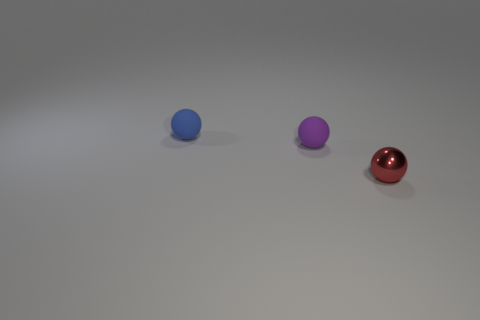What shape is the small object that is to the right of the tiny blue matte object and behind the red metallic sphere?
Offer a very short reply. Sphere. How many tiny things are on the right side of the small matte sphere that is in front of the tiny blue matte ball?
Make the answer very short. 1. Are the tiny object that is to the left of the tiny purple rubber sphere and the purple sphere made of the same material?
Your response must be concise. Yes. Is there any other thing that has the same material as the red sphere?
Provide a short and direct response. No. What is the size of the sphere in front of the rubber ball that is in front of the small blue rubber object?
Your response must be concise. Small. There is a rubber thing that is behind the matte sphere on the right side of the small matte sphere on the left side of the purple ball; what is its size?
Provide a succinct answer. Small. There is a tiny matte object in front of the blue matte sphere; does it have the same shape as the tiny rubber thing to the left of the tiny purple matte sphere?
Make the answer very short. Yes. How many other things are there of the same color as the tiny metallic sphere?
Provide a succinct answer. 0. Does the ball behind the purple ball have the same size as the red metal object?
Make the answer very short. Yes. Do the object that is on the left side of the small purple ball and the tiny purple thing in front of the small blue matte ball have the same material?
Your response must be concise. Yes. 